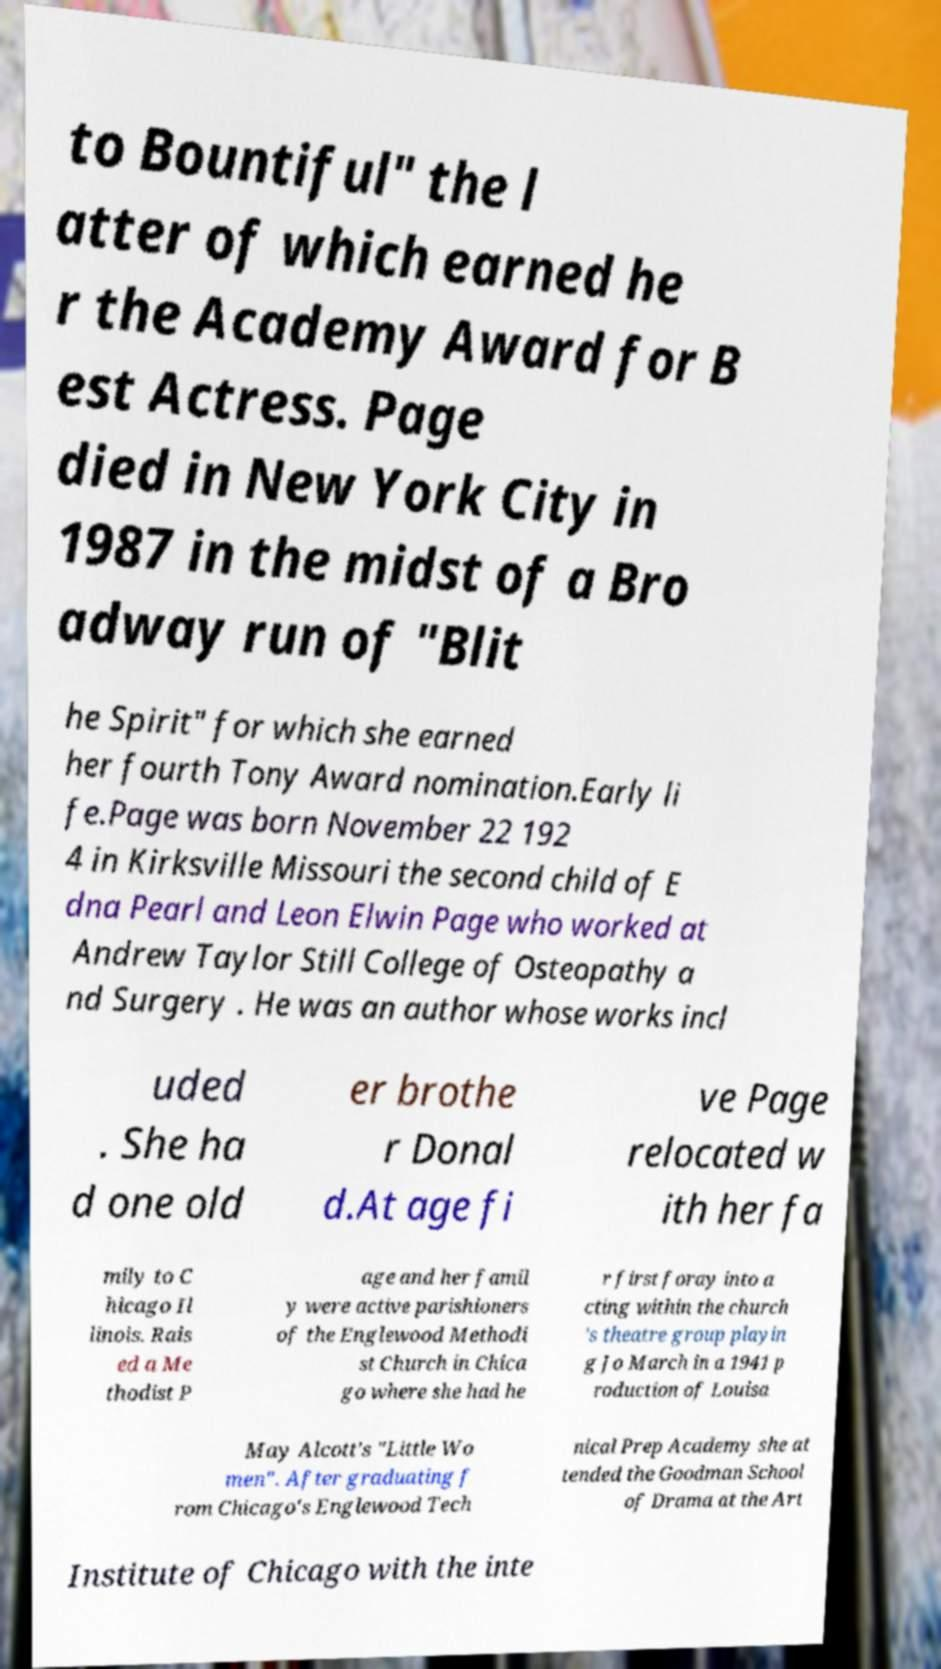Could you assist in decoding the text presented in this image and type it out clearly? to Bountiful" the l atter of which earned he r the Academy Award for B est Actress. Page died in New York City in 1987 in the midst of a Bro adway run of "Blit he Spirit" for which she earned her fourth Tony Award nomination.Early li fe.Page was born November 22 192 4 in Kirksville Missouri the second child of E dna Pearl and Leon Elwin Page who worked at Andrew Taylor Still College of Osteopathy a nd Surgery . He was an author whose works incl uded . She ha d one old er brothe r Donal d.At age fi ve Page relocated w ith her fa mily to C hicago Il linois. Rais ed a Me thodist P age and her famil y were active parishioners of the Englewood Methodi st Church in Chica go where she had he r first foray into a cting within the church 's theatre group playin g Jo March in a 1941 p roduction of Louisa May Alcott's "Little Wo men". After graduating f rom Chicago's Englewood Tech nical Prep Academy she at tended the Goodman School of Drama at the Art Institute of Chicago with the inte 